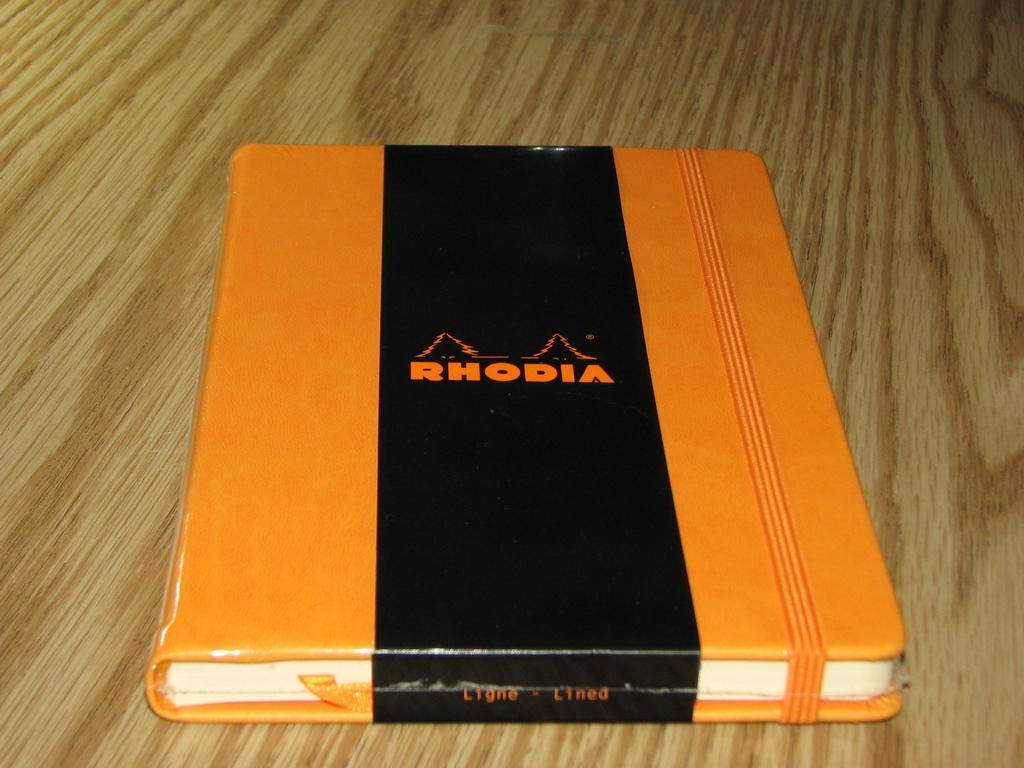Provide a one-sentence caption for the provided image. The bright orange color on the RHODIA journal is quite pretty. 